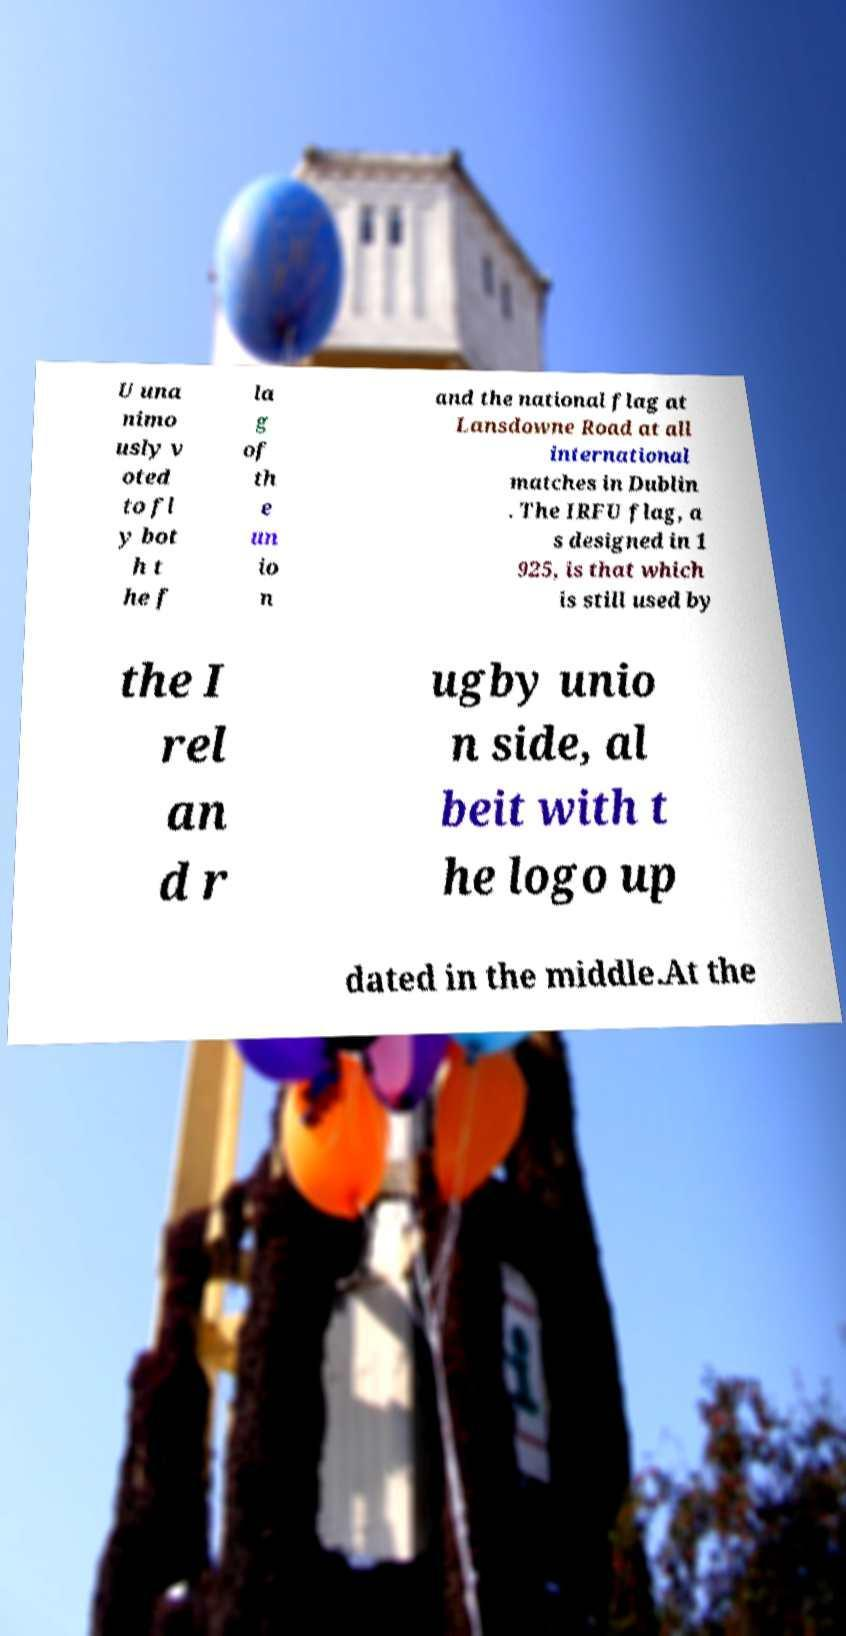Please identify and transcribe the text found in this image. U una nimo usly v oted to fl y bot h t he f la g of th e un io n and the national flag at Lansdowne Road at all international matches in Dublin . The IRFU flag, a s designed in 1 925, is that which is still used by the I rel an d r ugby unio n side, al beit with t he logo up dated in the middle.At the 